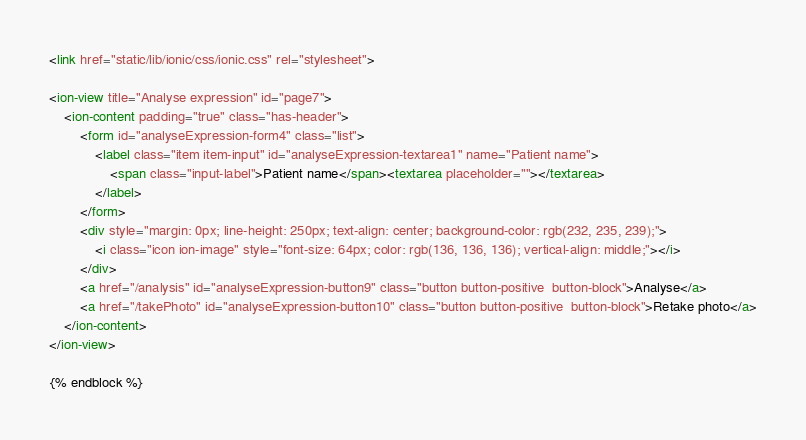<code> <loc_0><loc_0><loc_500><loc_500><_HTML_><link href="static/lib/ionic/css/ionic.css" rel="stylesheet">

<ion-view title="Analyse expression" id="page7">
    <ion-content padding="true" class="has-header">
        <form id="analyseExpression-form4" class="list">
            <label class="item item-input" id="analyseExpression-textarea1" name="Patient name">
                <span class="input-label">Patient name</span><textarea placeholder=""></textarea>
            </label>
        </form>
        <div style="margin: 0px; line-height: 250px; text-align: center; background-color: rgb(232, 235, 239);">
            <i class="icon ion-image" style="font-size: 64px; color: rgb(136, 136, 136); vertical-align: middle;"></i>
        </div>
        <a href="/analysis" id="analyseExpression-button9" class="button button-positive  button-block">Analyse</a>
        <a href="/takePhoto" id="analyseExpression-button10" class="button button-positive  button-block">Retake photo</a>
    </ion-content>
</ion-view>

{% endblock %}</code> 